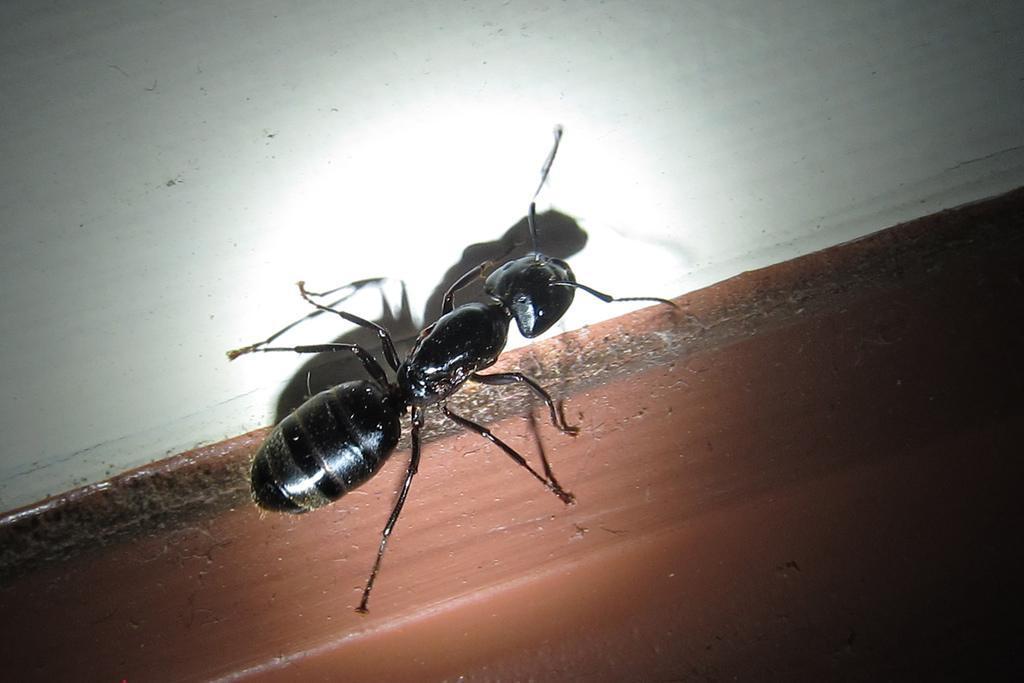Can you describe this image briefly? In this image I can see an insect in black color and the insect is on the white and brown color surface. 